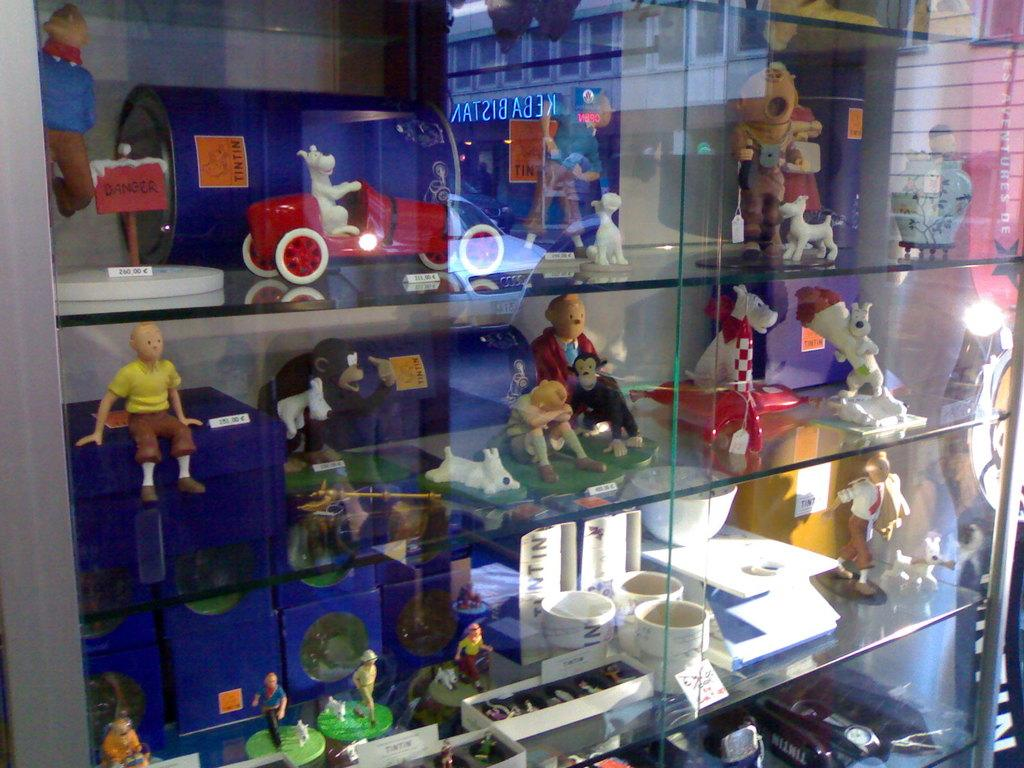What type of establishment might the image be taken in? The image might be taken in a store. What can be seen on the shelves in the image? There are many toys visible on the shelves in the image. What material might the shelves be made of? The presence of glass in the image suggests that the shelves might be made of glass or have glass components. Can you see any animals interacting with the toys in the image? There are no animals visible in the image. Are there any police officers present in the image? There are no police officers visible in the image. 